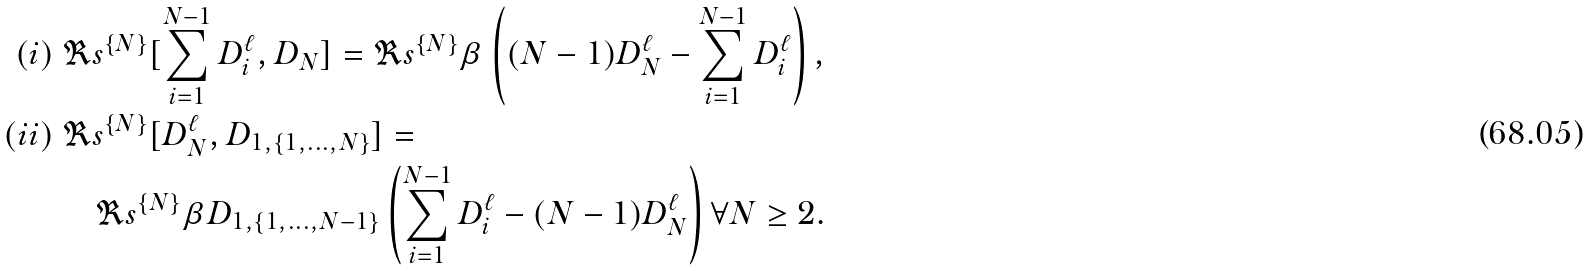<formula> <loc_0><loc_0><loc_500><loc_500>( i ) \ & \Re s ^ { \{ N \} } [ \sum _ { i = 1 } ^ { N - 1 } D _ { i } ^ { \ell } , D _ { N } ] = \Re s ^ { \{ N \} } \beta \left ( ( N - 1 ) D _ { N } ^ { \ell } - \sum _ { i = 1 } ^ { N - 1 } D _ { i } ^ { \ell } \right ) , \\ ( i i ) \ & \Re s ^ { \{ N \} } [ D _ { N } ^ { \ell } , D _ { 1 , \{ 1 , \dots , N \} } ] = \\ & \quad \Re s ^ { \{ N \} } \beta D _ { 1 , \{ 1 , \dots , N - 1 \} } \left ( \sum _ { i = 1 } ^ { N - 1 } D _ { i } ^ { \ell } - ( N - 1 ) D _ { N } ^ { \ell } \right ) \forall N \geq 2 .</formula> 